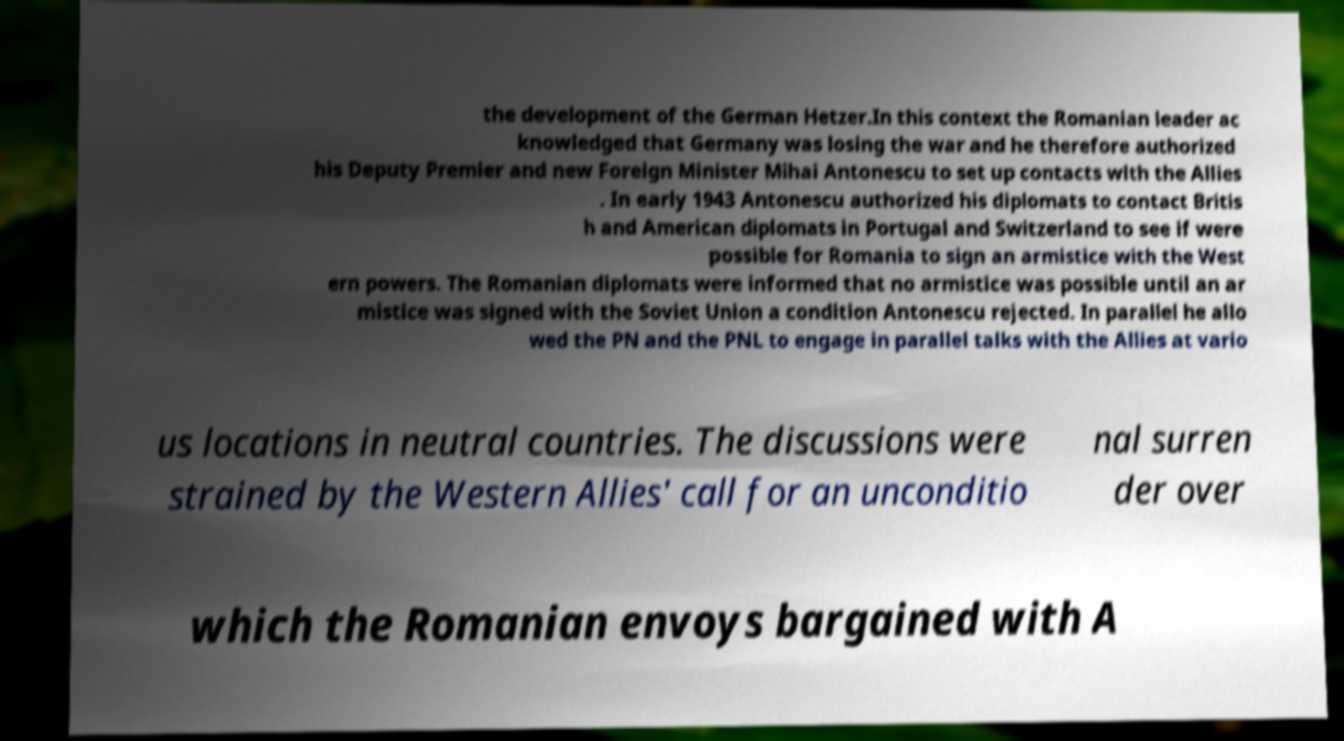Could you extract and type out the text from this image? the development of the German Hetzer.In this context the Romanian leader ac knowledged that Germany was losing the war and he therefore authorized his Deputy Premier and new Foreign Minister Mihai Antonescu to set up contacts with the Allies . In early 1943 Antonescu authorized his diplomats to contact Britis h and American diplomats in Portugal and Switzerland to see if were possible for Romania to sign an armistice with the West ern powers. The Romanian diplomats were informed that no armistice was possible until an ar mistice was signed with the Soviet Union a condition Antonescu rejected. In parallel he allo wed the PN and the PNL to engage in parallel talks with the Allies at vario us locations in neutral countries. The discussions were strained by the Western Allies' call for an unconditio nal surren der over which the Romanian envoys bargained with A 